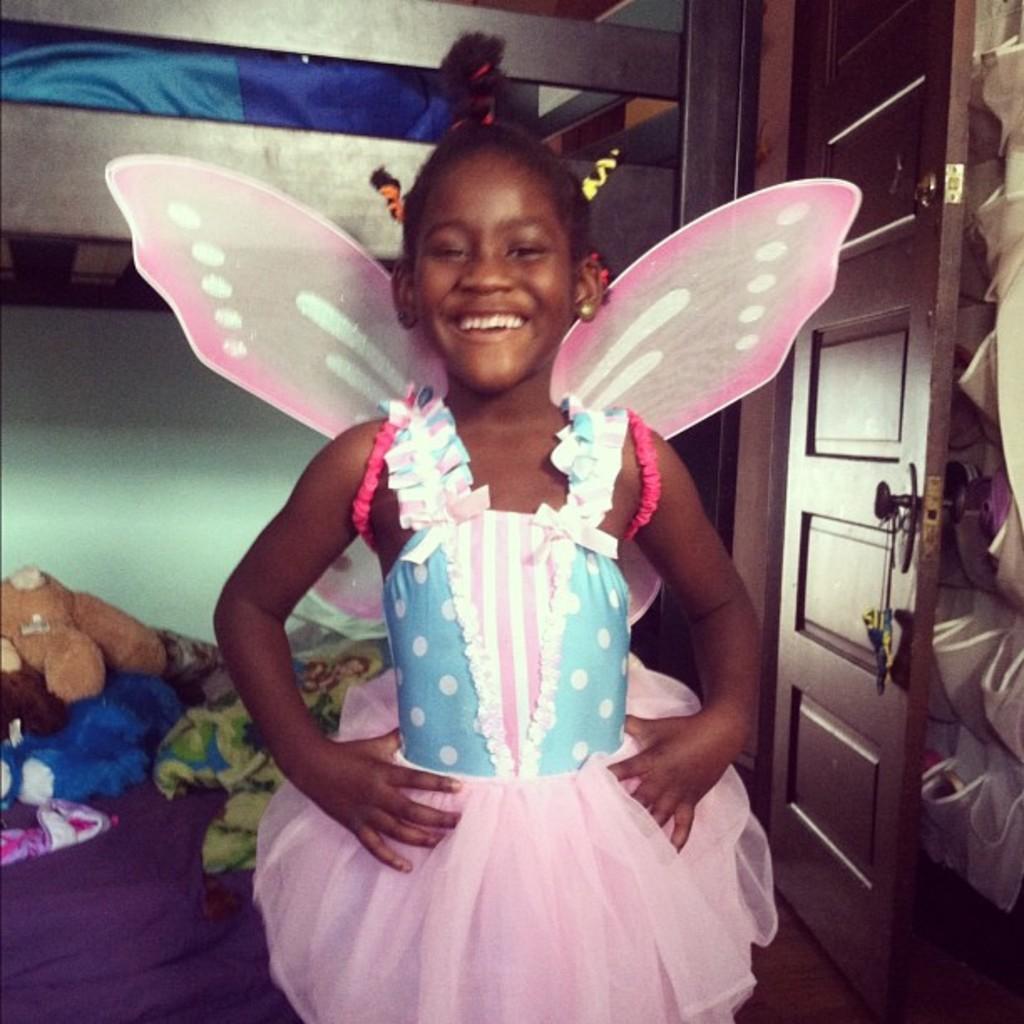Please provide a concise description of this image. In this image there is a girl standing and smiling, and in the background there is a door, there are toys on the bed , and there are some items. 